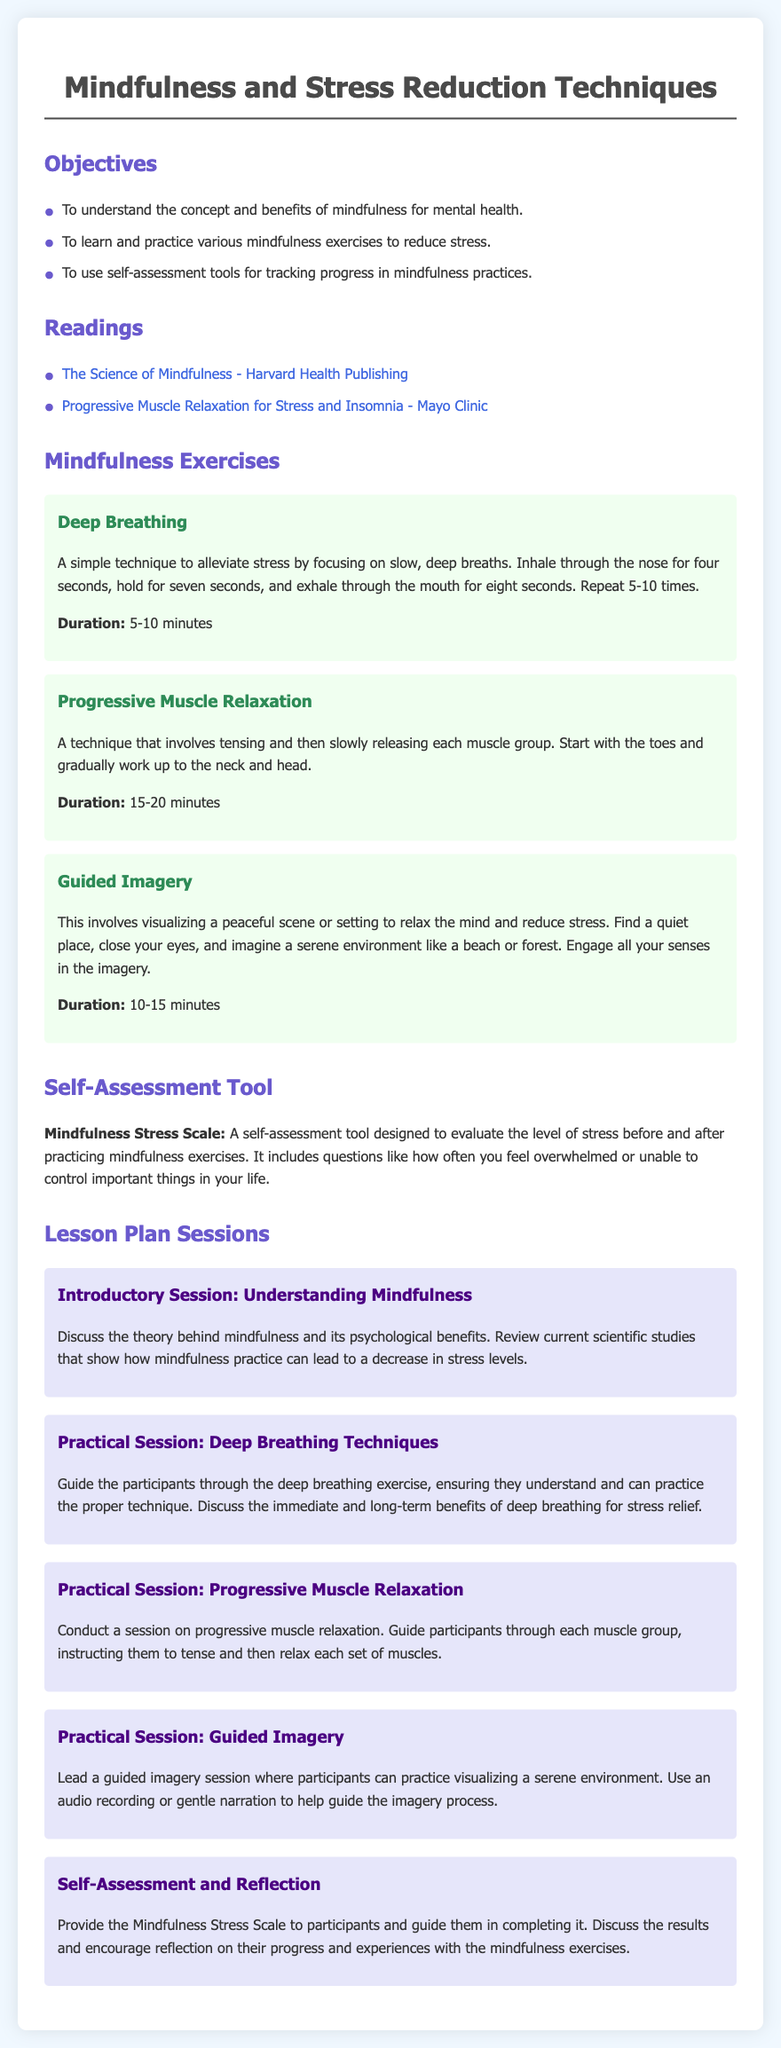What are the objectives of the lesson? The objectives include understanding the concept of mindfulness, learning various mindfulness exercises, and using self-assessment tools for tracking progress.
Answer: Understanding the concept and benefits of mindfulness for mental health, learning and practicing various mindfulness exercises to reduce stress, using self-assessment tools for tracking progress in mindfulness practices What is the duration of the Deep Breathing exercise? The duration is specifically mentioned in the content for the Deep Breathing exercise.
Answer: 5-10 minutes What technique involves tensing and releasing muscle groups? This information relates to a specific mindfulness exercise mentioned in the document.
Answer: Progressive Muscle Relaxation What self-assessment tool is mentioned in the lesson plan? The document specifies the name of the self-assessment tool used to evaluate stress levels.
Answer: Mindfulness Stress Scale How many practical sessions are included in the lesson plan? The total number of practical sessions can be found by counting them in the document.
Answer: Four What is the main focus of the Introductory Session? This question addresses the main topic of the Introductory Session as described in the lesson plan.
Answer: Understanding Mindfulness What kind of imagery does the Guided Imagery exercise involve? This question asks for specific details regarding the imagery type utilized in the exercise.
Answer: Visualizing a peaceful scene or setting What is the relationship between mindfulness and mental health mentioned in the lesson objectives? This question addresses the impact of mindfulness as stated in the objectives section of the lesson plan.
Answer: The benefits of mindfulness for mental health 